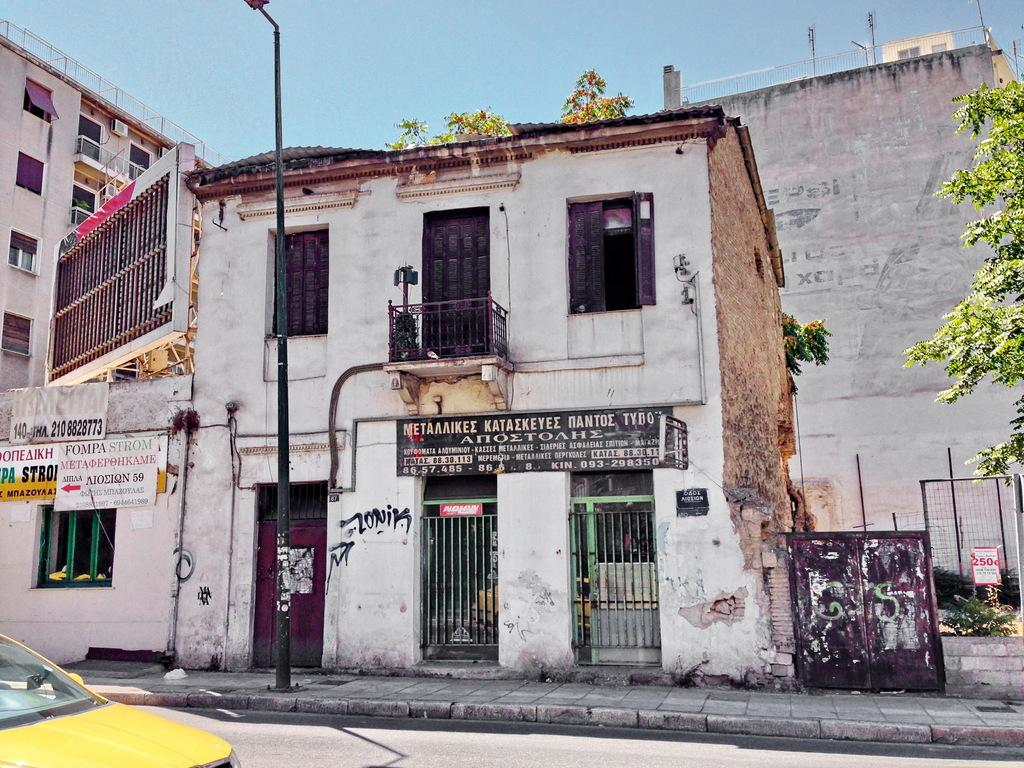What is located in the center of the image? There are buildings in the center of the image. What can be seen in the image besides the buildings? There is a pole, trees in the background, the sky, and a car at the bottom of the image on the road. What type of vegetation is visible in the background of the image? There are trees in the background of the image. What is visible in the sky in the image? The sky is visible in the background of the image. What is the weight of the bait used by the father in the image? There is no father or bait present in the image. 